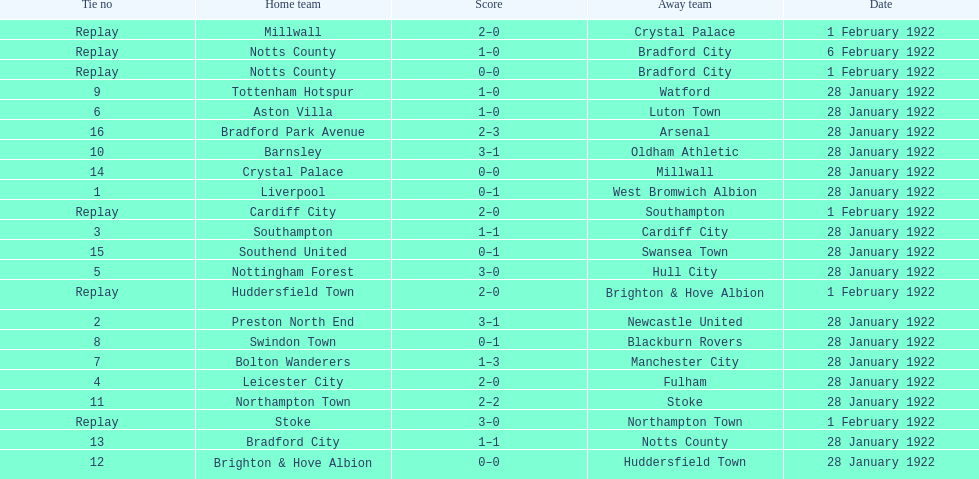Who is the first home team listed as having a score of 3-1? Preston North End. 